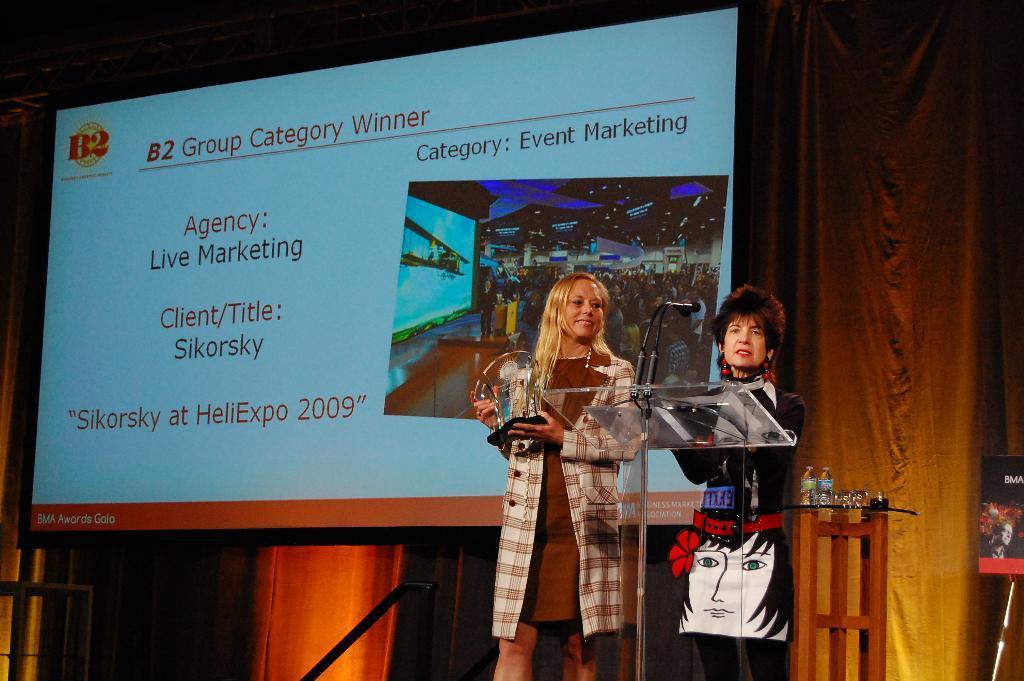Could you give a brief overview of what you see in this image? In this image, we can see a person standing and holding an object with her hand. There is an another person standing in front of the podium. There are bottles on the table which is in the bottom right of the image. There is a screen in the middle of the image. 